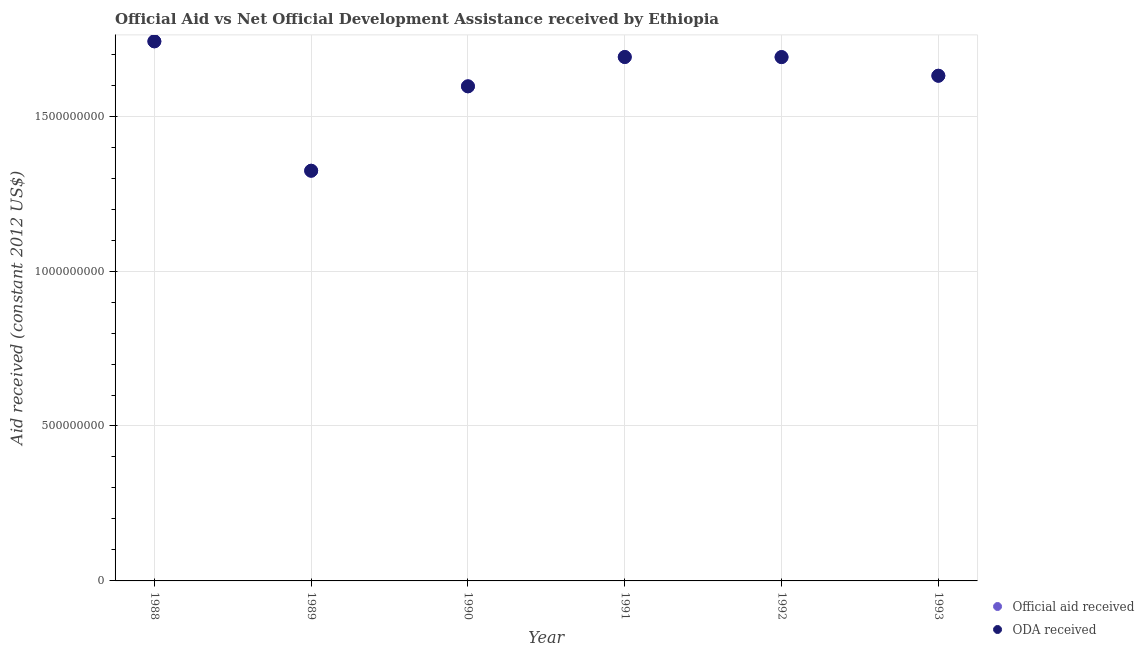How many different coloured dotlines are there?
Keep it short and to the point. 2. What is the oda received in 1991?
Offer a terse response. 1.69e+09. Across all years, what is the maximum official aid received?
Ensure brevity in your answer.  1.74e+09. Across all years, what is the minimum oda received?
Give a very brief answer. 1.32e+09. In which year was the official aid received maximum?
Ensure brevity in your answer.  1988. In which year was the official aid received minimum?
Provide a short and direct response. 1989. What is the total official aid received in the graph?
Give a very brief answer. 9.67e+09. What is the difference between the oda received in 1991 and that in 1993?
Give a very brief answer. 6.05e+07. What is the difference between the official aid received in 1989 and the oda received in 1993?
Your response must be concise. -3.07e+08. What is the average official aid received per year?
Ensure brevity in your answer.  1.61e+09. In the year 1990, what is the difference between the official aid received and oda received?
Offer a very short reply. 0. In how many years, is the official aid received greater than 300000000 US$?
Keep it short and to the point. 6. What is the ratio of the oda received in 1991 to that in 1993?
Provide a short and direct response. 1.04. Is the oda received in 1991 less than that in 1992?
Give a very brief answer. No. Is the difference between the oda received in 1989 and 1992 greater than the difference between the official aid received in 1989 and 1992?
Offer a very short reply. No. What is the difference between the highest and the second highest official aid received?
Ensure brevity in your answer.  5.05e+07. What is the difference between the highest and the lowest oda received?
Your answer should be compact. 4.18e+08. In how many years, is the official aid received greater than the average official aid received taken over all years?
Provide a succinct answer. 4. Is the oda received strictly less than the official aid received over the years?
Your answer should be compact. No. How many dotlines are there?
Ensure brevity in your answer.  2. What is the difference between two consecutive major ticks on the Y-axis?
Ensure brevity in your answer.  5.00e+08. Are the values on the major ticks of Y-axis written in scientific E-notation?
Offer a very short reply. No. Does the graph contain any zero values?
Offer a terse response. No. Does the graph contain grids?
Offer a terse response. Yes. What is the title of the graph?
Offer a very short reply. Official Aid vs Net Official Development Assistance received by Ethiopia . What is the label or title of the X-axis?
Give a very brief answer. Year. What is the label or title of the Y-axis?
Ensure brevity in your answer.  Aid received (constant 2012 US$). What is the Aid received (constant 2012 US$) in Official aid received in 1988?
Your answer should be very brief. 1.74e+09. What is the Aid received (constant 2012 US$) of ODA received in 1988?
Give a very brief answer. 1.74e+09. What is the Aid received (constant 2012 US$) of Official aid received in 1989?
Make the answer very short. 1.32e+09. What is the Aid received (constant 2012 US$) in ODA received in 1989?
Keep it short and to the point. 1.32e+09. What is the Aid received (constant 2012 US$) of Official aid received in 1990?
Make the answer very short. 1.60e+09. What is the Aid received (constant 2012 US$) in ODA received in 1990?
Keep it short and to the point. 1.60e+09. What is the Aid received (constant 2012 US$) in Official aid received in 1991?
Provide a succinct answer. 1.69e+09. What is the Aid received (constant 2012 US$) in ODA received in 1991?
Your answer should be very brief. 1.69e+09. What is the Aid received (constant 2012 US$) of Official aid received in 1992?
Your response must be concise. 1.69e+09. What is the Aid received (constant 2012 US$) in ODA received in 1992?
Offer a very short reply. 1.69e+09. What is the Aid received (constant 2012 US$) in Official aid received in 1993?
Make the answer very short. 1.63e+09. What is the Aid received (constant 2012 US$) of ODA received in 1993?
Make the answer very short. 1.63e+09. Across all years, what is the maximum Aid received (constant 2012 US$) in Official aid received?
Your response must be concise. 1.74e+09. Across all years, what is the maximum Aid received (constant 2012 US$) of ODA received?
Provide a succinct answer. 1.74e+09. Across all years, what is the minimum Aid received (constant 2012 US$) in Official aid received?
Ensure brevity in your answer.  1.32e+09. Across all years, what is the minimum Aid received (constant 2012 US$) of ODA received?
Keep it short and to the point. 1.32e+09. What is the total Aid received (constant 2012 US$) of Official aid received in the graph?
Make the answer very short. 9.67e+09. What is the total Aid received (constant 2012 US$) of ODA received in the graph?
Your answer should be compact. 9.67e+09. What is the difference between the Aid received (constant 2012 US$) of Official aid received in 1988 and that in 1989?
Offer a terse response. 4.18e+08. What is the difference between the Aid received (constant 2012 US$) of ODA received in 1988 and that in 1989?
Your answer should be very brief. 4.18e+08. What is the difference between the Aid received (constant 2012 US$) of Official aid received in 1988 and that in 1990?
Offer a terse response. 1.45e+08. What is the difference between the Aid received (constant 2012 US$) in ODA received in 1988 and that in 1990?
Provide a short and direct response. 1.45e+08. What is the difference between the Aid received (constant 2012 US$) in Official aid received in 1988 and that in 1991?
Your answer should be very brief. 5.05e+07. What is the difference between the Aid received (constant 2012 US$) of ODA received in 1988 and that in 1991?
Your answer should be compact. 5.05e+07. What is the difference between the Aid received (constant 2012 US$) of Official aid received in 1988 and that in 1992?
Ensure brevity in your answer.  5.08e+07. What is the difference between the Aid received (constant 2012 US$) of ODA received in 1988 and that in 1992?
Ensure brevity in your answer.  5.08e+07. What is the difference between the Aid received (constant 2012 US$) in Official aid received in 1988 and that in 1993?
Provide a succinct answer. 1.11e+08. What is the difference between the Aid received (constant 2012 US$) in ODA received in 1988 and that in 1993?
Provide a succinct answer. 1.11e+08. What is the difference between the Aid received (constant 2012 US$) of Official aid received in 1989 and that in 1990?
Offer a terse response. -2.72e+08. What is the difference between the Aid received (constant 2012 US$) in ODA received in 1989 and that in 1990?
Your answer should be very brief. -2.72e+08. What is the difference between the Aid received (constant 2012 US$) of Official aid received in 1989 and that in 1991?
Offer a very short reply. -3.67e+08. What is the difference between the Aid received (constant 2012 US$) in ODA received in 1989 and that in 1991?
Your answer should be compact. -3.67e+08. What is the difference between the Aid received (constant 2012 US$) of Official aid received in 1989 and that in 1992?
Provide a short and direct response. -3.67e+08. What is the difference between the Aid received (constant 2012 US$) of ODA received in 1989 and that in 1992?
Your answer should be very brief. -3.67e+08. What is the difference between the Aid received (constant 2012 US$) of Official aid received in 1989 and that in 1993?
Your answer should be very brief. -3.07e+08. What is the difference between the Aid received (constant 2012 US$) of ODA received in 1989 and that in 1993?
Offer a terse response. -3.07e+08. What is the difference between the Aid received (constant 2012 US$) in Official aid received in 1990 and that in 1991?
Ensure brevity in your answer.  -9.46e+07. What is the difference between the Aid received (constant 2012 US$) in ODA received in 1990 and that in 1991?
Provide a succinct answer. -9.46e+07. What is the difference between the Aid received (constant 2012 US$) in Official aid received in 1990 and that in 1992?
Provide a succinct answer. -9.44e+07. What is the difference between the Aid received (constant 2012 US$) in ODA received in 1990 and that in 1992?
Provide a short and direct response. -9.44e+07. What is the difference between the Aid received (constant 2012 US$) in Official aid received in 1990 and that in 1993?
Your answer should be very brief. -3.42e+07. What is the difference between the Aid received (constant 2012 US$) of ODA received in 1990 and that in 1993?
Provide a succinct answer. -3.42e+07. What is the difference between the Aid received (constant 2012 US$) in Official aid received in 1991 and that in 1992?
Make the answer very short. 2.70e+05. What is the difference between the Aid received (constant 2012 US$) of ODA received in 1991 and that in 1992?
Offer a very short reply. 2.70e+05. What is the difference between the Aid received (constant 2012 US$) of Official aid received in 1991 and that in 1993?
Offer a very short reply. 6.05e+07. What is the difference between the Aid received (constant 2012 US$) in ODA received in 1991 and that in 1993?
Provide a short and direct response. 6.05e+07. What is the difference between the Aid received (constant 2012 US$) in Official aid received in 1992 and that in 1993?
Provide a succinct answer. 6.02e+07. What is the difference between the Aid received (constant 2012 US$) of ODA received in 1992 and that in 1993?
Give a very brief answer. 6.02e+07. What is the difference between the Aid received (constant 2012 US$) of Official aid received in 1988 and the Aid received (constant 2012 US$) of ODA received in 1989?
Offer a very short reply. 4.18e+08. What is the difference between the Aid received (constant 2012 US$) of Official aid received in 1988 and the Aid received (constant 2012 US$) of ODA received in 1990?
Keep it short and to the point. 1.45e+08. What is the difference between the Aid received (constant 2012 US$) in Official aid received in 1988 and the Aid received (constant 2012 US$) in ODA received in 1991?
Offer a terse response. 5.05e+07. What is the difference between the Aid received (constant 2012 US$) in Official aid received in 1988 and the Aid received (constant 2012 US$) in ODA received in 1992?
Keep it short and to the point. 5.08e+07. What is the difference between the Aid received (constant 2012 US$) in Official aid received in 1988 and the Aid received (constant 2012 US$) in ODA received in 1993?
Your answer should be compact. 1.11e+08. What is the difference between the Aid received (constant 2012 US$) of Official aid received in 1989 and the Aid received (constant 2012 US$) of ODA received in 1990?
Make the answer very short. -2.72e+08. What is the difference between the Aid received (constant 2012 US$) of Official aid received in 1989 and the Aid received (constant 2012 US$) of ODA received in 1991?
Provide a succinct answer. -3.67e+08. What is the difference between the Aid received (constant 2012 US$) in Official aid received in 1989 and the Aid received (constant 2012 US$) in ODA received in 1992?
Your answer should be compact. -3.67e+08. What is the difference between the Aid received (constant 2012 US$) of Official aid received in 1989 and the Aid received (constant 2012 US$) of ODA received in 1993?
Your answer should be very brief. -3.07e+08. What is the difference between the Aid received (constant 2012 US$) of Official aid received in 1990 and the Aid received (constant 2012 US$) of ODA received in 1991?
Your answer should be very brief. -9.46e+07. What is the difference between the Aid received (constant 2012 US$) of Official aid received in 1990 and the Aid received (constant 2012 US$) of ODA received in 1992?
Keep it short and to the point. -9.44e+07. What is the difference between the Aid received (constant 2012 US$) of Official aid received in 1990 and the Aid received (constant 2012 US$) of ODA received in 1993?
Your response must be concise. -3.42e+07. What is the difference between the Aid received (constant 2012 US$) in Official aid received in 1991 and the Aid received (constant 2012 US$) in ODA received in 1992?
Provide a short and direct response. 2.70e+05. What is the difference between the Aid received (constant 2012 US$) in Official aid received in 1991 and the Aid received (constant 2012 US$) in ODA received in 1993?
Provide a succinct answer. 6.05e+07. What is the difference between the Aid received (constant 2012 US$) in Official aid received in 1992 and the Aid received (constant 2012 US$) in ODA received in 1993?
Offer a very short reply. 6.02e+07. What is the average Aid received (constant 2012 US$) of Official aid received per year?
Keep it short and to the point. 1.61e+09. What is the average Aid received (constant 2012 US$) in ODA received per year?
Keep it short and to the point. 1.61e+09. In the year 1990, what is the difference between the Aid received (constant 2012 US$) of Official aid received and Aid received (constant 2012 US$) of ODA received?
Provide a succinct answer. 0. What is the ratio of the Aid received (constant 2012 US$) of Official aid received in 1988 to that in 1989?
Ensure brevity in your answer.  1.32. What is the ratio of the Aid received (constant 2012 US$) in ODA received in 1988 to that in 1989?
Your response must be concise. 1.32. What is the ratio of the Aid received (constant 2012 US$) of Official aid received in 1988 to that in 1990?
Keep it short and to the point. 1.09. What is the ratio of the Aid received (constant 2012 US$) of Official aid received in 1988 to that in 1991?
Provide a succinct answer. 1.03. What is the ratio of the Aid received (constant 2012 US$) of ODA received in 1988 to that in 1991?
Ensure brevity in your answer.  1.03. What is the ratio of the Aid received (constant 2012 US$) in Official aid received in 1988 to that in 1992?
Your answer should be compact. 1.03. What is the ratio of the Aid received (constant 2012 US$) of ODA received in 1988 to that in 1992?
Offer a terse response. 1.03. What is the ratio of the Aid received (constant 2012 US$) in Official aid received in 1988 to that in 1993?
Offer a terse response. 1.07. What is the ratio of the Aid received (constant 2012 US$) in ODA received in 1988 to that in 1993?
Make the answer very short. 1.07. What is the ratio of the Aid received (constant 2012 US$) in Official aid received in 1989 to that in 1990?
Your answer should be very brief. 0.83. What is the ratio of the Aid received (constant 2012 US$) of ODA received in 1989 to that in 1990?
Your answer should be compact. 0.83. What is the ratio of the Aid received (constant 2012 US$) of Official aid received in 1989 to that in 1991?
Offer a terse response. 0.78. What is the ratio of the Aid received (constant 2012 US$) of ODA received in 1989 to that in 1991?
Provide a short and direct response. 0.78. What is the ratio of the Aid received (constant 2012 US$) of Official aid received in 1989 to that in 1992?
Keep it short and to the point. 0.78. What is the ratio of the Aid received (constant 2012 US$) in ODA received in 1989 to that in 1992?
Make the answer very short. 0.78. What is the ratio of the Aid received (constant 2012 US$) in Official aid received in 1989 to that in 1993?
Provide a succinct answer. 0.81. What is the ratio of the Aid received (constant 2012 US$) of ODA received in 1989 to that in 1993?
Provide a succinct answer. 0.81. What is the ratio of the Aid received (constant 2012 US$) in Official aid received in 1990 to that in 1991?
Your answer should be compact. 0.94. What is the ratio of the Aid received (constant 2012 US$) of ODA received in 1990 to that in 1991?
Your answer should be compact. 0.94. What is the ratio of the Aid received (constant 2012 US$) in Official aid received in 1990 to that in 1992?
Your answer should be very brief. 0.94. What is the ratio of the Aid received (constant 2012 US$) of ODA received in 1990 to that in 1992?
Keep it short and to the point. 0.94. What is the ratio of the Aid received (constant 2012 US$) in Official aid received in 1991 to that in 1992?
Make the answer very short. 1. What is the ratio of the Aid received (constant 2012 US$) of ODA received in 1991 to that in 1992?
Offer a terse response. 1. What is the ratio of the Aid received (constant 2012 US$) in Official aid received in 1991 to that in 1993?
Provide a succinct answer. 1.04. What is the ratio of the Aid received (constant 2012 US$) of ODA received in 1991 to that in 1993?
Offer a terse response. 1.04. What is the ratio of the Aid received (constant 2012 US$) of Official aid received in 1992 to that in 1993?
Your response must be concise. 1.04. What is the ratio of the Aid received (constant 2012 US$) in ODA received in 1992 to that in 1993?
Provide a succinct answer. 1.04. What is the difference between the highest and the second highest Aid received (constant 2012 US$) in Official aid received?
Offer a very short reply. 5.05e+07. What is the difference between the highest and the second highest Aid received (constant 2012 US$) in ODA received?
Make the answer very short. 5.05e+07. What is the difference between the highest and the lowest Aid received (constant 2012 US$) in Official aid received?
Offer a terse response. 4.18e+08. What is the difference between the highest and the lowest Aid received (constant 2012 US$) of ODA received?
Your response must be concise. 4.18e+08. 